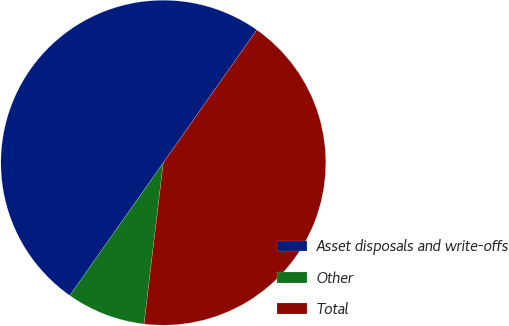Convert chart. <chart><loc_0><loc_0><loc_500><loc_500><pie_chart><fcel>Asset disposals and write-offs<fcel>Other<fcel>Total<nl><fcel>50.0%<fcel>7.87%<fcel>42.13%<nl></chart> 